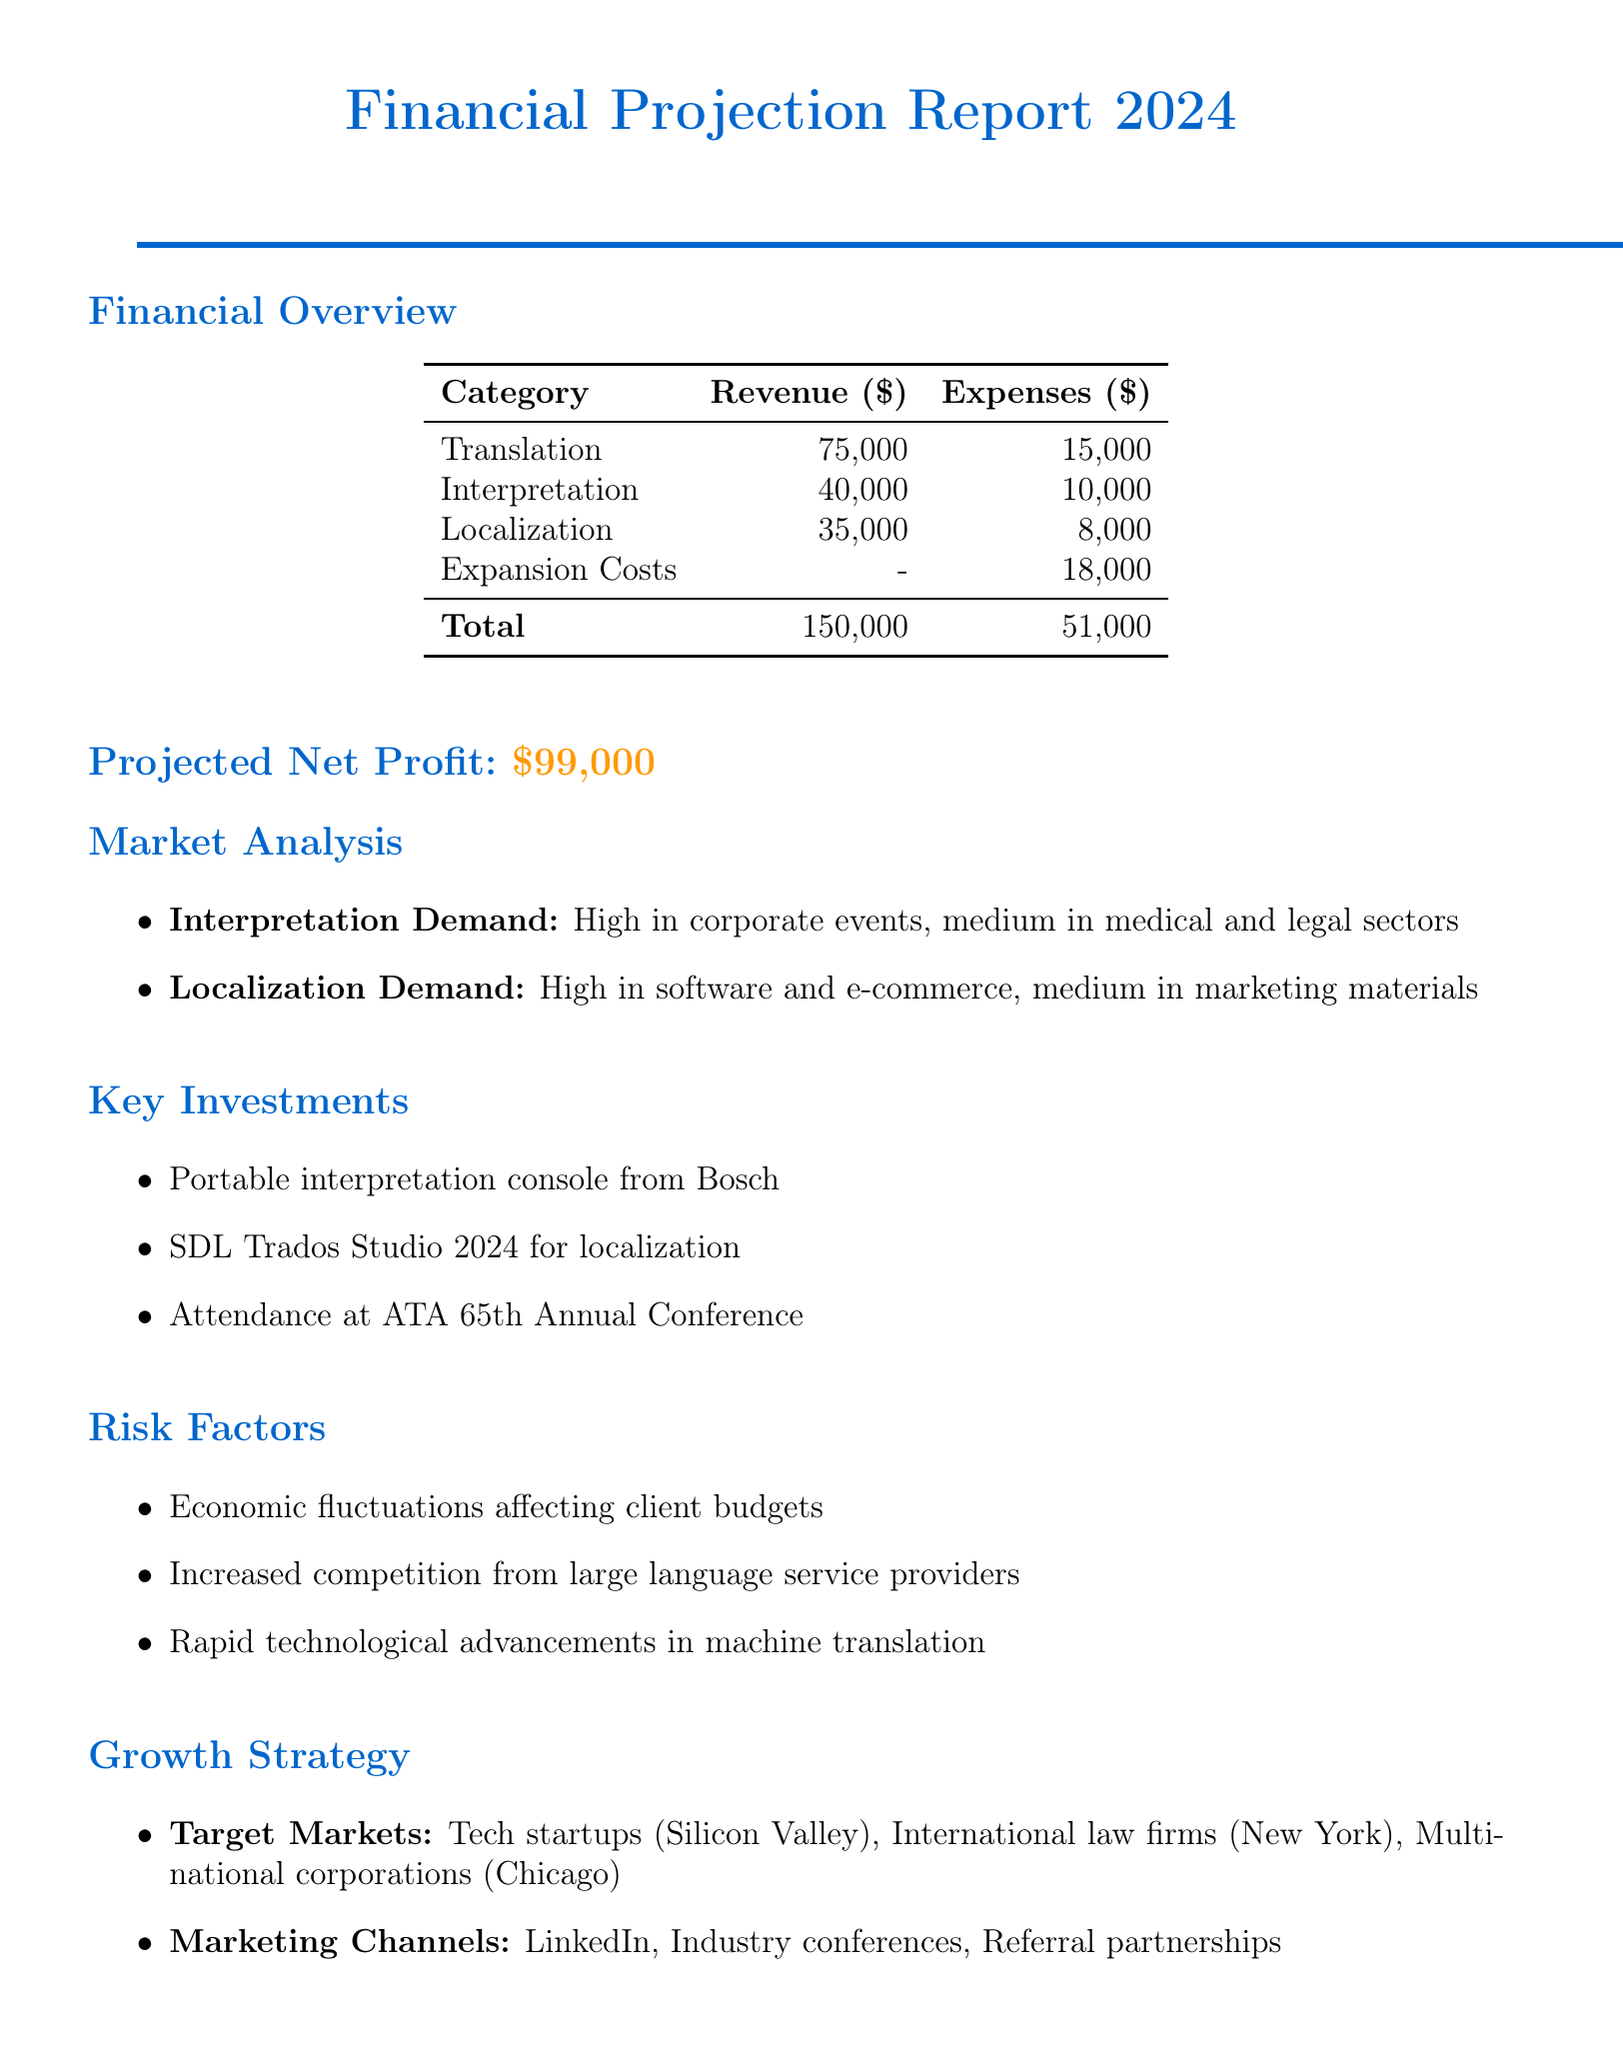What is the projected total revenue? The projected total revenue for 2024 is $150,000 as mentioned in the financial overview.
Answer: $150,000 What are the total expenses projected for 2024? The total expenses projected for 2024 are $48,000, which includes expenses from current and new services.
Answer: $48,000 What is the estimated revenue from localization services? The estimated revenue from localization services is $35,000, as specified in the new services section.
Answer: $35,000 What is the key investment for interpretation services? The key investment for interpretation services is the portable interpretation console from Bosch, listed under key investments.
Answer: Portable interpretation console from Bosch What are the target markets identified in the growth strategy? The target markets identified include tech startups in Silicon Valley, international law firms in New York, and multinational corporations in Chicago.
Answer: Tech startups in Silicon Valley, International law firms in New York, Multinational corporations in Chicago What is the net profit projected for 2024? The projected net profit for 2024 is $102,000, calculated by subtracting total expenses from total revenue.
Answer: $102,000 What is the estimated cost for training in interpretation services? The estimated cost for training in interpretation services is $2,000, as detailed in the new services section under estimated costs.
Answer: $2,000 Which marketing channel is mentioned for outreach? The marketing channel mentioned for outreach is LinkedIn professional network, as indicated in the growth strategy section.
Answer: LinkedIn professional network What is the demand for localization services in the eCommerce sector? The demand for localization services in the eCommerce sector is classified as high in the market analysis section.
Answer: High 